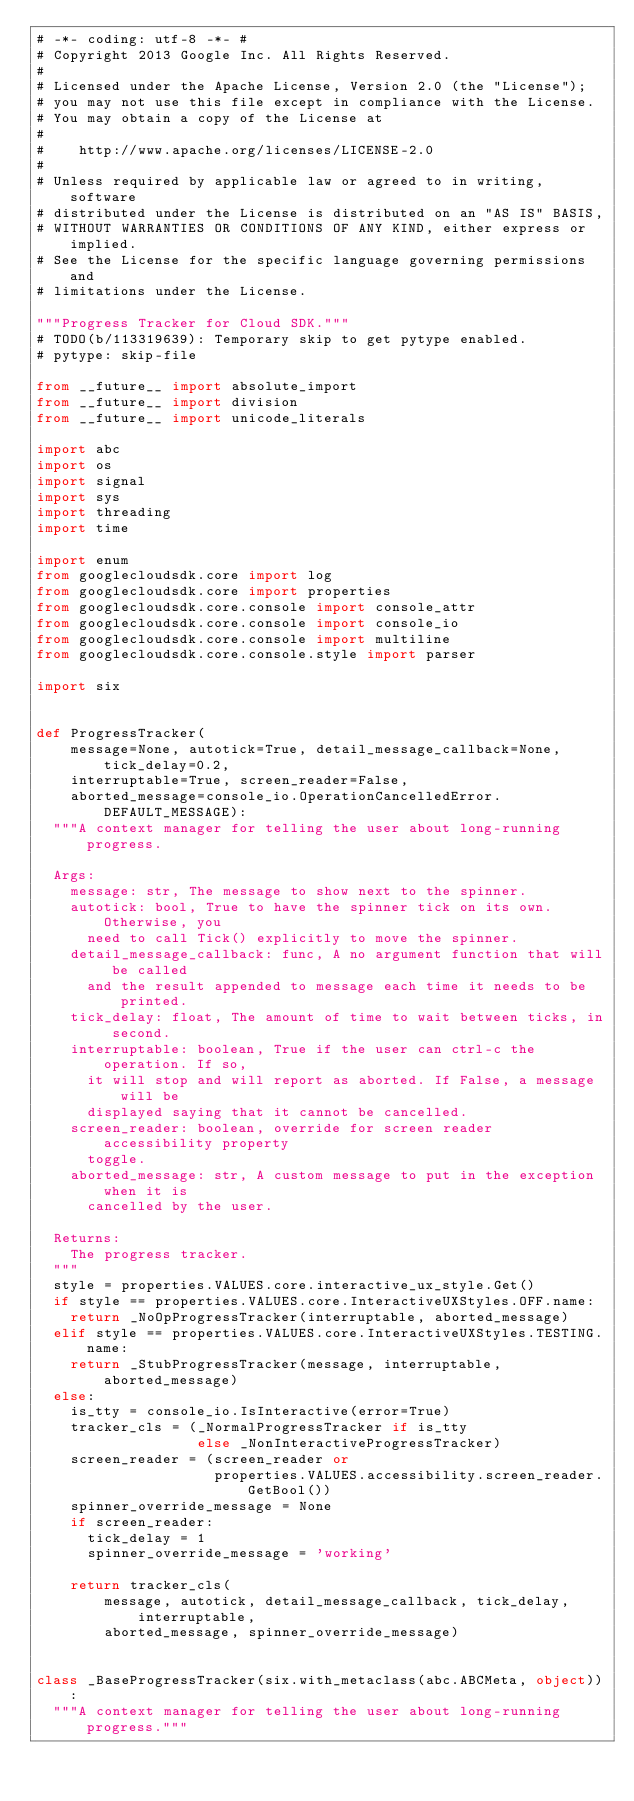<code> <loc_0><loc_0><loc_500><loc_500><_Python_># -*- coding: utf-8 -*- #
# Copyright 2013 Google Inc. All Rights Reserved.
#
# Licensed under the Apache License, Version 2.0 (the "License");
# you may not use this file except in compliance with the License.
# You may obtain a copy of the License at
#
#    http://www.apache.org/licenses/LICENSE-2.0
#
# Unless required by applicable law or agreed to in writing, software
# distributed under the License is distributed on an "AS IS" BASIS,
# WITHOUT WARRANTIES OR CONDITIONS OF ANY KIND, either express or implied.
# See the License for the specific language governing permissions and
# limitations under the License.

"""Progress Tracker for Cloud SDK."""
# TODO(b/113319639): Temporary skip to get pytype enabled.
# pytype: skip-file

from __future__ import absolute_import
from __future__ import division
from __future__ import unicode_literals

import abc
import os
import signal
import sys
import threading
import time

import enum
from googlecloudsdk.core import log
from googlecloudsdk.core import properties
from googlecloudsdk.core.console import console_attr
from googlecloudsdk.core.console import console_io
from googlecloudsdk.core.console import multiline
from googlecloudsdk.core.console.style import parser

import six


def ProgressTracker(
    message=None, autotick=True, detail_message_callback=None, tick_delay=0.2,
    interruptable=True, screen_reader=False,
    aborted_message=console_io.OperationCancelledError.DEFAULT_MESSAGE):
  """A context manager for telling the user about long-running progress.

  Args:
    message: str, The message to show next to the spinner.
    autotick: bool, True to have the spinner tick on its own. Otherwise, you
      need to call Tick() explicitly to move the spinner.
    detail_message_callback: func, A no argument function that will be called
      and the result appended to message each time it needs to be printed.
    tick_delay: float, The amount of time to wait between ticks, in second.
    interruptable: boolean, True if the user can ctrl-c the operation. If so,
      it will stop and will report as aborted. If False, a message will be
      displayed saying that it cannot be cancelled.
    screen_reader: boolean, override for screen reader accessibility property
      toggle.
    aborted_message: str, A custom message to put in the exception when it is
      cancelled by the user.

  Returns:
    The progress tracker.
  """
  style = properties.VALUES.core.interactive_ux_style.Get()
  if style == properties.VALUES.core.InteractiveUXStyles.OFF.name:
    return _NoOpProgressTracker(interruptable, aborted_message)
  elif style == properties.VALUES.core.InteractiveUXStyles.TESTING.name:
    return _StubProgressTracker(message, interruptable, aborted_message)
  else:
    is_tty = console_io.IsInteractive(error=True)
    tracker_cls = (_NormalProgressTracker if is_tty
                   else _NonInteractiveProgressTracker)
    screen_reader = (screen_reader or
                     properties.VALUES.accessibility.screen_reader.GetBool())
    spinner_override_message = None
    if screen_reader:
      tick_delay = 1
      spinner_override_message = 'working'

    return tracker_cls(
        message, autotick, detail_message_callback, tick_delay, interruptable,
        aborted_message, spinner_override_message)


class _BaseProgressTracker(six.with_metaclass(abc.ABCMeta, object)):
  """A context manager for telling the user about long-running progress."""
</code> 